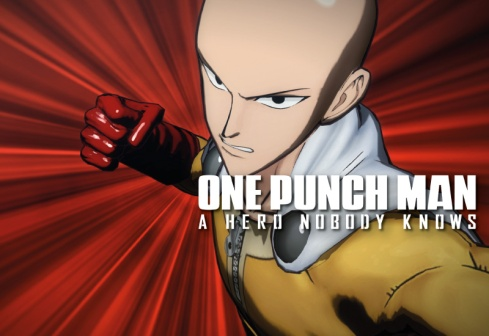What is the significance of Saitama's expression in this image? Saitama's expression in this image is one of intense focus and determination. This look highlights his readiness to engage in battle or deliver a powerful punch, which is central to his character as an overwhelmingly strong hero. Despite his simplistic and often nonchalant demeanor, this expression reveals a rare moment of seriousness, emphasizing the strength and resolve that lie beneath his often-comedic exterior. Can you give more background about the creation of Saitama as a character? Saitama was created by the artist ONE as a parody of traditional superhero tropes. His character is designed to subvert typical hero narratives; while most heroes struggle to defeat their enemies, Saitama defeats his foes with a single punch, which leaves him perpetually unchallenged and bored. This unique premise led to a fresh take on the superhero genre, making him a standout character who navigates the ennui of overwhelming power. The simplicity of his design—bald head, plain costume—contrasts with his incredible abilities, further emphasizing the satirical nature of his character. Imagine that Saitama is transported to a different universe where he meets another powerful hero. How would he react? If Saitama were transported to a different universe and met another powerful hero, his reaction would likely be one of polite indifference at first. Saitama's primary desire is to find an opponent that can challenge him, so if this new hero could provide a sense of competition or excitement, he might show more interest. However, given his laid-back personality, he might initially approach the situation with his usual nonchalance, potentially leading to humorous interactions before any serious combat ensues. 